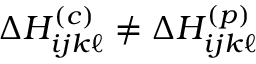Convert formula to latex. <formula><loc_0><loc_0><loc_500><loc_500>\Delta H _ { i j k \ell } ^ { ( c ) } \neq \Delta H _ { i j k \ell } ^ { ( p ) }</formula> 